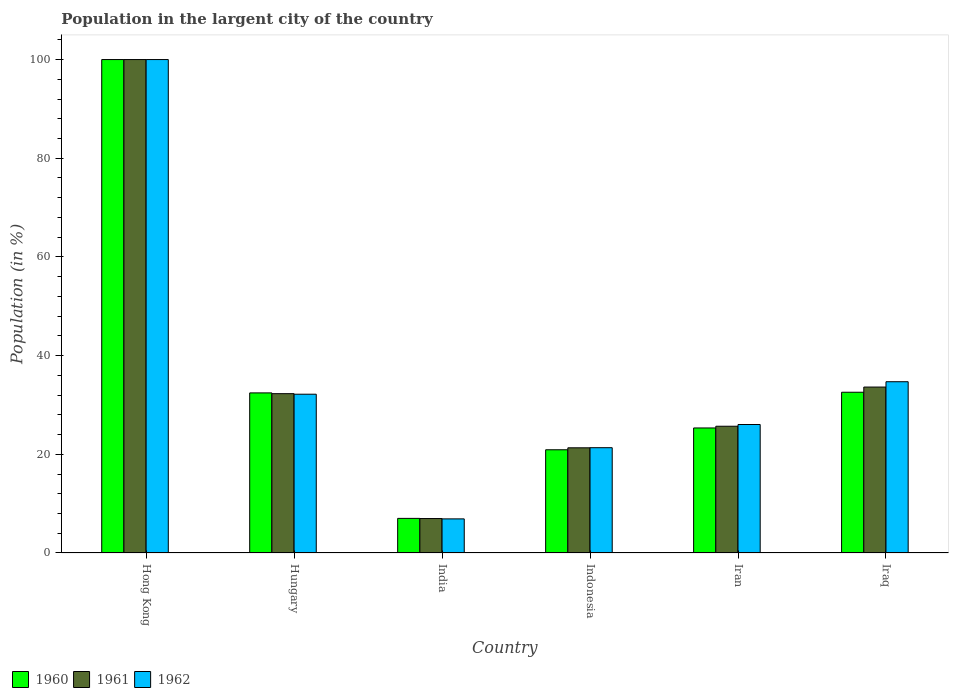How many different coloured bars are there?
Ensure brevity in your answer.  3. How many groups of bars are there?
Provide a short and direct response. 6. Are the number of bars per tick equal to the number of legend labels?
Your answer should be very brief. Yes. How many bars are there on the 1st tick from the left?
Give a very brief answer. 3. How many bars are there on the 3rd tick from the right?
Your response must be concise. 3. What is the label of the 1st group of bars from the left?
Offer a very short reply. Hong Kong. In how many cases, is the number of bars for a given country not equal to the number of legend labels?
Keep it short and to the point. 0. What is the percentage of population in the largent city in 1961 in India?
Make the answer very short. 6.98. Across all countries, what is the maximum percentage of population in the largent city in 1962?
Ensure brevity in your answer.  100. Across all countries, what is the minimum percentage of population in the largent city in 1961?
Make the answer very short. 6.98. In which country was the percentage of population in the largent city in 1961 maximum?
Your response must be concise. Hong Kong. What is the total percentage of population in the largent city in 1962 in the graph?
Your answer should be very brief. 221.17. What is the difference between the percentage of population in the largent city in 1962 in Hungary and that in Iran?
Provide a short and direct response. 6.14. What is the difference between the percentage of population in the largent city in 1961 in Iraq and the percentage of population in the largent city in 1960 in Indonesia?
Offer a very short reply. 12.71. What is the average percentage of population in the largent city in 1962 per country?
Make the answer very short. 36.86. What is the difference between the percentage of population in the largent city of/in 1960 and percentage of population in the largent city of/in 1961 in India?
Make the answer very short. 0.03. In how many countries, is the percentage of population in the largent city in 1962 greater than 96 %?
Offer a terse response. 1. What is the ratio of the percentage of population in the largent city in 1961 in Hong Kong to that in Iraq?
Your answer should be very brief. 2.97. What is the difference between the highest and the second highest percentage of population in the largent city in 1960?
Offer a terse response. 0.13. What is the difference between the highest and the lowest percentage of population in the largent city in 1961?
Keep it short and to the point. 93.02. In how many countries, is the percentage of population in the largent city in 1961 greater than the average percentage of population in the largent city in 1961 taken over all countries?
Ensure brevity in your answer.  1. What does the 2nd bar from the left in Iran represents?
Your response must be concise. 1961. What does the 1st bar from the right in Iran represents?
Make the answer very short. 1962. What is the difference between two consecutive major ticks on the Y-axis?
Your response must be concise. 20. Are the values on the major ticks of Y-axis written in scientific E-notation?
Your response must be concise. No. Does the graph contain any zero values?
Provide a short and direct response. No. Where does the legend appear in the graph?
Provide a succinct answer. Bottom left. How many legend labels are there?
Your answer should be compact. 3. What is the title of the graph?
Provide a succinct answer. Population in the largent city of the country. Does "1983" appear as one of the legend labels in the graph?
Give a very brief answer. No. What is the label or title of the X-axis?
Keep it short and to the point. Country. What is the label or title of the Y-axis?
Ensure brevity in your answer.  Population (in %). What is the Population (in %) of 1960 in Hong Kong?
Your answer should be compact. 100. What is the Population (in %) of 1960 in Hungary?
Keep it short and to the point. 32.44. What is the Population (in %) of 1961 in Hungary?
Make the answer very short. 32.29. What is the Population (in %) of 1962 in Hungary?
Provide a succinct answer. 32.18. What is the Population (in %) in 1960 in India?
Provide a short and direct response. 7.01. What is the Population (in %) of 1961 in India?
Your answer should be very brief. 6.98. What is the Population (in %) in 1962 in India?
Offer a terse response. 6.91. What is the Population (in %) of 1960 in Indonesia?
Your answer should be compact. 20.92. What is the Population (in %) in 1961 in Indonesia?
Provide a succinct answer. 21.32. What is the Population (in %) of 1962 in Indonesia?
Your answer should be very brief. 21.34. What is the Population (in %) of 1960 in Iran?
Make the answer very short. 25.34. What is the Population (in %) of 1961 in Iran?
Offer a terse response. 25.68. What is the Population (in %) in 1962 in Iran?
Your answer should be compact. 26.04. What is the Population (in %) of 1960 in Iraq?
Offer a very short reply. 32.58. What is the Population (in %) in 1961 in Iraq?
Keep it short and to the point. 33.63. What is the Population (in %) in 1962 in Iraq?
Make the answer very short. 34.71. Across all countries, what is the minimum Population (in %) of 1960?
Your response must be concise. 7.01. Across all countries, what is the minimum Population (in %) of 1961?
Provide a short and direct response. 6.98. Across all countries, what is the minimum Population (in %) of 1962?
Provide a short and direct response. 6.91. What is the total Population (in %) of 1960 in the graph?
Give a very brief answer. 218.29. What is the total Population (in %) of 1961 in the graph?
Give a very brief answer. 219.9. What is the total Population (in %) in 1962 in the graph?
Make the answer very short. 221.17. What is the difference between the Population (in %) in 1960 in Hong Kong and that in Hungary?
Provide a short and direct response. 67.56. What is the difference between the Population (in %) in 1961 in Hong Kong and that in Hungary?
Provide a short and direct response. 67.71. What is the difference between the Population (in %) of 1962 in Hong Kong and that in Hungary?
Your answer should be compact. 67.82. What is the difference between the Population (in %) of 1960 in Hong Kong and that in India?
Ensure brevity in your answer.  92.99. What is the difference between the Population (in %) in 1961 in Hong Kong and that in India?
Keep it short and to the point. 93.02. What is the difference between the Population (in %) in 1962 in Hong Kong and that in India?
Your response must be concise. 93.09. What is the difference between the Population (in %) of 1960 in Hong Kong and that in Indonesia?
Offer a very short reply. 79.08. What is the difference between the Population (in %) in 1961 in Hong Kong and that in Indonesia?
Keep it short and to the point. 78.68. What is the difference between the Population (in %) of 1962 in Hong Kong and that in Indonesia?
Give a very brief answer. 78.66. What is the difference between the Population (in %) of 1960 in Hong Kong and that in Iran?
Provide a succinct answer. 74.66. What is the difference between the Population (in %) in 1961 in Hong Kong and that in Iran?
Keep it short and to the point. 74.32. What is the difference between the Population (in %) of 1962 in Hong Kong and that in Iran?
Keep it short and to the point. 73.96. What is the difference between the Population (in %) in 1960 in Hong Kong and that in Iraq?
Ensure brevity in your answer.  67.42. What is the difference between the Population (in %) of 1961 in Hong Kong and that in Iraq?
Ensure brevity in your answer.  66.37. What is the difference between the Population (in %) in 1962 in Hong Kong and that in Iraq?
Make the answer very short. 65.29. What is the difference between the Population (in %) in 1960 in Hungary and that in India?
Give a very brief answer. 25.43. What is the difference between the Population (in %) in 1961 in Hungary and that in India?
Keep it short and to the point. 25.31. What is the difference between the Population (in %) of 1962 in Hungary and that in India?
Provide a succinct answer. 25.27. What is the difference between the Population (in %) of 1960 in Hungary and that in Indonesia?
Your answer should be compact. 11.53. What is the difference between the Population (in %) of 1961 in Hungary and that in Indonesia?
Your answer should be very brief. 10.97. What is the difference between the Population (in %) of 1962 in Hungary and that in Indonesia?
Provide a short and direct response. 10.84. What is the difference between the Population (in %) in 1960 in Hungary and that in Iran?
Make the answer very short. 7.11. What is the difference between the Population (in %) in 1961 in Hungary and that in Iran?
Your answer should be compact. 6.6. What is the difference between the Population (in %) in 1962 in Hungary and that in Iran?
Make the answer very short. 6.14. What is the difference between the Population (in %) of 1960 in Hungary and that in Iraq?
Give a very brief answer. -0.13. What is the difference between the Population (in %) in 1961 in Hungary and that in Iraq?
Keep it short and to the point. -1.34. What is the difference between the Population (in %) in 1962 in Hungary and that in Iraq?
Offer a terse response. -2.53. What is the difference between the Population (in %) in 1960 in India and that in Indonesia?
Give a very brief answer. -13.91. What is the difference between the Population (in %) of 1961 in India and that in Indonesia?
Keep it short and to the point. -14.33. What is the difference between the Population (in %) of 1962 in India and that in Indonesia?
Offer a terse response. -14.43. What is the difference between the Population (in %) in 1960 in India and that in Iran?
Provide a short and direct response. -18.33. What is the difference between the Population (in %) of 1961 in India and that in Iran?
Offer a very short reply. -18.7. What is the difference between the Population (in %) in 1962 in India and that in Iran?
Your answer should be very brief. -19.13. What is the difference between the Population (in %) in 1960 in India and that in Iraq?
Provide a succinct answer. -25.57. What is the difference between the Population (in %) in 1961 in India and that in Iraq?
Ensure brevity in your answer.  -26.64. What is the difference between the Population (in %) of 1962 in India and that in Iraq?
Your answer should be compact. -27.8. What is the difference between the Population (in %) in 1960 in Indonesia and that in Iran?
Provide a short and direct response. -4.42. What is the difference between the Population (in %) of 1961 in Indonesia and that in Iran?
Give a very brief answer. -4.37. What is the difference between the Population (in %) in 1962 in Indonesia and that in Iran?
Provide a short and direct response. -4.7. What is the difference between the Population (in %) of 1960 in Indonesia and that in Iraq?
Your answer should be very brief. -11.66. What is the difference between the Population (in %) in 1961 in Indonesia and that in Iraq?
Provide a succinct answer. -12.31. What is the difference between the Population (in %) in 1962 in Indonesia and that in Iraq?
Your answer should be compact. -13.37. What is the difference between the Population (in %) of 1960 in Iran and that in Iraq?
Ensure brevity in your answer.  -7.24. What is the difference between the Population (in %) in 1961 in Iran and that in Iraq?
Ensure brevity in your answer.  -7.94. What is the difference between the Population (in %) in 1962 in Iran and that in Iraq?
Keep it short and to the point. -8.67. What is the difference between the Population (in %) in 1960 in Hong Kong and the Population (in %) in 1961 in Hungary?
Make the answer very short. 67.71. What is the difference between the Population (in %) of 1960 in Hong Kong and the Population (in %) of 1962 in Hungary?
Give a very brief answer. 67.82. What is the difference between the Population (in %) in 1961 in Hong Kong and the Population (in %) in 1962 in Hungary?
Offer a terse response. 67.82. What is the difference between the Population (in %) of 1960 in Hong Kong and the Population (in %) of 1961 in India?
Your answer should be compact. 93.02. What is the difference between the Population (in %) of 1960 in Hong Kong and the Population (in %) of 1962 in India?
Your answer should be compact. 93.09. What is the difference between the Population (in %) of 1961 in Hong Kong and the Population (in %) of 1962 in India?
Ensure brevity in your answer.  93.09. What is the difference between the Population (in %) of 1960 in Hong Kong and the Population (in %) of 1961 in Indonesia?
Provide a succinct answer. 78.68. What is the difference between the Population (in %) of 1960 in Hong Kong and the Population (in %) of 1962 in Indonesia?
Offer a very short reply. 78.66. What is the difference between the Population (in %) in 1961 in Hong Kong and the Population (in %) in 1962 in Indonesia?
Give a very brief answer. 78.66. What is the difference between the Population (in %) of 1960 in Hong Kong and the Population (in %) of 1961 in Iran?
Give a very brief answer. 74.32. What is the difference between the Population (in %) of 1960 in Hong Kong and the Population (in %) of 1962 in Iran?
Provide a succinct answer. 73.96. What is the difference between the Population (in %) of 1961 in Hong Kong and the Population (in %) of 1962 in Iran?
Your answer should be compact. 73.96. What is the difference between the Population (in %) in 1960 in Hong Kong and the Population (in %) in 1961 in Iraq?
Your answer should be very brief. 66.37. What is the difference between the Population (in %) of 1960 in Hong Kong and the Population (in %) of 1962 in Iraq?
Keep it short and to the point. 65.29. What is the difference between the Population (in %) of 1961 in Hong Kong and the Population (in %) of 1962 in Iraq?
Your answer should be very brief. 65.29. What is the difference between the Population (in %) of 1960 in Hungary and the Population (in %) of 1961 in India?
Provide a succinct answer. 25.46. What is the difference between the Population (in %) in 1960 in Hungary and the Population (in %) in 1962 in India?
Provide a succinct answer. 25.53. What is the difference between the Population (in %) of 1961 in Hungary and the Population (in %) of 1962 in India?
Keep it short and to the point. 25.38. What is the difference between the Population (in %) in 1960 in Hungary and the Population (in %) in 1961 in Indonesia?
Give a very brief answer. 11.13. What is the difference between the Population (in %) of 1960 in Hungary and the Population (in %) of 1962 in Indonesia?
Your answer should be compact. 11.11. What is the difference between the Population (in %) in 1961 in Hungary and the Population (in %) in 1962 in Indonesia?
Offer a very short reply. 10.95. What is the difference between the Population (in %) of 1960 in Hungary and the Population (in %) of 1961 in Iran?
Give a very brief answer. 6.76. What is the difference between the Population (in %) of 1960 in Hungary and the Population (in %) of 1962 in Iran?
Ensure brevity in your answer.  6.41. What is the difference between the Population (in %) of 1961 in Hungary and the Population (in %) of 1962 in Iran?
Keep it short and to the point. 6.25. What is the difference between the Population (in %) in 1960 in Hungary and the Population (in %) in 1961 in Iraq?
Your answer should be very brief. -1.18. What is the difference between the Population (in %) of 1960 in Hungary and the Population (in %) of 1962 in Iraq?
Your answer should be very brief. -2.26. What is the difference between the Population (in %) in 1961 in Hungary and the Population (in %) in 1962 in Iraq?
Your answer should be compact. -2.42. What is the difference between the Population (in %) in 1960 in India and the Population (in %) in 1961 in Indonesia?
Provide a succinct answer. -14.3. What is the difference between the Population (in %) of 1960 in India and the Population (in %) of 1962 in Indonesia?
Your response must be concise. -14.32. What is the difference between the Population (in %) in 1961 in India and the Population (in %) in 1962 in Indonesia?
Make the answer very short. -14.35. What is the difference between the Population (in %) in 1960 in India and the Population (in %) in 1961 in Iran?
Offer a terse response. -18.67. What is the difference between the Population (in %) in 1960 in India and the Population (in %) in 1962 in Iran?
Your answer should be compact. -19.02. What is the difference between the Population (in %) of 1961 in India and the Population (in %) of 1962 in Iran?
Ensure brevity in your answer.  -19.06. What is the difference between the Population (in %) of 1960 in India and the Population (in %) of 1961 in Iraq?
Your answer should be compact. -26.61. What is the difference between the Population (in %) of 1960 in India and the Population (in %) of 1962 in Iraq?
Offer a terse response. -27.69. What is the difference between the Population (in %) in 1961 in India and the Population (in %) in 1962 in Iraq?
Give a very brief answer. -27.72. What is the difference between the Population (in %) of 1960 in Indonesia and the Population (in %) of 1961 in Iran?
Provide a succinct answer. -4.77. What is the difference between the Population (in %) in 1960 in Indonesia and the Population (in %) in 1962 in Iran?
Your answer should be very brief. -5.12. What is the difference between the Population (in %) in 1961 in Indonesia and the Population (in %) in 1962 in Iran?
Provide a succinct answer. -4.72. What is the difference between the Population (in %) in 1960 in Indonesia and the Population (in %) in 1961 in Iraq?
Keep it short and to the point. -12.71. What is the difference between the Population (in %) of 1960 in Indonesia and the Population (in %) of 1962 in Iraq?
Your answer should be very brief. -13.79. What is the difference between the Population (in %) of 1961 in Indonesia and the Population (in %) of 1962 in Iraq?
Offer a terse response. -13.39. What is the difference between the Population (in %) of 1960 in Iran and the Population (in %) of 1961 in Iraq?
Provide a succinct answer. -8.29. What is the difference between the Population (in %) in 1960 in Iran and the Population (in %) in 1962 in Iraq?
Your response must be concise. -9.37. What is the difference between the Population (in %) in 1961 in Iran and the Population (in %) in 1962 in Iraq?
Your response must be concise. -9.02. What is the average Population (in %) of 1960 per country?
Your answer should be very brief. 36.38. What is the average Population (in %) in 1961 per country?
Give a very brief answer. 36.65. What is the average Population (in %) of 1962 per country?
Provide a succinct answer. 36.86. What is the difference between the Population (in %) in 1960 and Population (in %) in 1962 in Hong Kong?
Ensure brevity in your answer.  0. What is the difference between the Population (in %) in 1960 and Population (in %) in 1961 in Hungary?
Ensure brevity in your answer.  0.16. What is the difference between the Population (in %) of 1960 and Population (in %) of 1962 in Hungary?
Ensure brevity in your answer.  0.27. What is the difference between the Population (in %) of 1961 and Population (in %) of 1962 in Hungary?
Offer a terse response. 0.11. What is the difference between the Population (in %) in 1960 and Population (in %) in 1961 in India?
Provide a short and direct response. 0.03. What is the difference between the Population (in %) in 1960 and Population (in %) in 1962 in India?
Offer a terse response. 0.1. What is the difference between the Population (in %) of 1961 and Population (in %) of 1962 in India?
Offer a terse response. 0.07. What is the difference between the Population (in %) of 1960 and Population (in %) of 1961 in Indonesia?
Ensure brevity in your answer.  -0.4. What is the difference between the Population (in %) in 1960 and Population (in %) in 1962 in Indonesia?
Make the answer very short. -0.42. What is the difference between the Population (in %) of 1961 and Population (in %) of 1962 in Indonesia?
Your response must be concise. -0.02. What is the difference between the Population (in %) in 1960 and Population (in %) in 1961 in Iran?
Provide a succinct answer. -0.35. What is the difference between the Population (in %) in 1960 and Population (in %) in 1962 in Iran?
Provide a short and direct response. -0.7. What is the difference between the Population (in %) of 1961 and Population (in %) of 1962 in Iran?
Offer a very short reply. -0.35. What is the difference between the Population (in %) in 1960 and Population (in %) in 1961 in Iraq?
Your response must be concise. -1.05. What is the difference between the Population (in %) in 1960 and Population (in %) in 1962 in Iraq?
Offer a very short reply. -2.13. What is the difference between the Population (in %) in 1961 and Population (in %) in 1962 in Iraq?
Make the answer very short. -1.08. What is the ratio of the Population (in %) of 1960 in Hong Kong to that in Hungary?
Keep it short and to the point. 3.08. What is the ratio of the Population (in %) in 1961 in Hong Kong to that in Hungary?
Your answer should be very brief. 3.1. What is the ratio of the Population (in %) of 1962 in Hong Kong to that in Hungary?
Ensure brevity in your answer.  3.11. What is the ratio of the Population (in %) of 1960 in Hong Kong to that in India?
Your answer should be very brief. 14.26. What is the ratio of the Population (in %) in 1961 in Hong Kong to that in India?
Provide a succinct answer. 14.32. What is the ratio of the Population (in %) in 1962 in Hong Kong to that in India?
Ensure brevity in your answer.  14.47. What is the ratio of the Population (in %) of 1960 in Hong Kong to that in Indonesia?
Your response must be concise. 4.78. What is the ratio of the Population (in %) in 1961 in Hong Kong to that in Indonesia?
Provide a short and direct response. 4.69. What is the ratio of the Population (in %) of 1962 in Hong Kong to that in Indonesia?
Your response must be concise. 4.69. What is the ratio of the Population (in %) of 1960 in Hong Kong to that in Iran?
Ensure brevity in your answer.  3.95. What is the ratio of the Population (in %) of 1961 in Hong Kong to that in Iran?
Give a very brief answer. 3.89. What is the ratio of the Population (in %) in 1962 in Hong Kong to that in Iran?
Your answer should be compact. 3.84. What is the ratio of the Population (in %) in 1960 in Hong Kong to that in Iraq?
Offer a terse response. 3.07. What is the ratio of the Population (in %) of 1961 in Hong Kong to that in Iraq?
Your response must be concise. 2.97. What is the ratio of the Population (in %) of 1962 in Hong Kong to that in Iraq?
Provide a succinct answer. 2.88. What is the ratio of the Population (in %) in 1960 in Hungary to that in India?
Give a very brief answer. 4.63. What is the ratio of the Population (in %) in 1961 in Hungary to that in India?
Ensure brevity in your answer.  4.62. What is the ratio of the Population (in %) in 1962 in Hungary to that in India?
Offer a very short reply. 4.66. What is the ratio of the Population (in %) of 1960 in Hungary to that in Indonesia?
Your answer should be compact. 1.55. What is the ratio of the Population (in %) in 1961 in Hungary to that in Indonesia?
Your response must be concise. 1.51. What is the ratio of the Population (in %) in 1962 in Hungary to that in Indonesia?
Offer a terse response. 1.51. What is the ratio of the Population (in %) of 1960 in Hungary to that in Iran?
Provide a succinct answer. 1.28. What is the ratio of the Population (in %) in 1961 in Hungary to that in Iran?
Keep it short and to the point. 1.26. What is the ratio of the Population (in %) in 1962 in Hungary to that in Iran?
Provide a succinct answer. 1.24. What is the ratio of the Population (in %) of 1960 in Hungary to that in Iraq?
Your answer should be very brief. 1. What is the ratio of the Population (in %) of 1961 in Hungary to that in Iraq?
Your answer should be very brief. 0.96. What is the ratio of the Population (in %) in 1962 in Hungary to that in Iraq?
Your response must be concise. 0.93. What is the ratio of the Population (in %) of 1960 in India to that in Indonesia?
Provide a short and direct response. 0.34. What is the ratio of the Population (in %) in 1961 in India to that in Indonesia?
Offer a very short reply. 0.33. What is the ratio of the Population (in %) of 1962 in India to that in Indonesia?
Your response must be concise. 0.32. What is the ratio of the Population (in %) of 1960 in India to that in Iran?
Keep it short and to the point. 0.28. What is the ratio of the Population (in %) of 1961 in India to that in Iran?
Offer a terse response. 0.27. What is the ratio of the Population (in %) in 1962 in India to that in Iran?
Keep it short and to the point. 0.27. What is the ratio of the Population (in %) in 1960 in India to that in Iraq?
Provide a succinct answer. 0.22. What is the ratio of the Population (in %) of 1961 in India to that in Iraq?
Your answer should be very brief. 0.21. What is the ratio of the Population (in %) in 1962 in India to that in Iraq?
Keep it short and to the point. 0.2. What is the ratio of the Population (in %) in 1960 in Indonesia to that in Iran?
Offer a terse response. 0.83. What is the ratio of the Population (in %) in 1961 in Indonesia to that in Iran?
Offer a very short reply. 0.83. What is the ratio of the Population (in %) of 1962 in Indonesia to that in Iran?
Make the answer very short. 0.82. What is the ratio of the Population (in %) in 1960 in Indonesia to that in Iraq?
Offer a very short reply. 0.64. What is the ratio of the Population (in %) of 1961 in Indonesia to that in Iraq?
Give a very brief answer. 0.63. What is the ratio of the Population (in %) of 1962 in Indonesia to that in Iraq?
Your answer should be compact. 0.61. What is the ratio of the Population (in %) of 1961 in Iran to that in Iraq?
Make the answer very short. 0.76. What is the ratio of the Population (in %) of 1962 in Iran to that in Iraq?
Keep it short and to the point. 0.75. What is the difference between the highest and the second highest Population (in %) in 1960?
Keep it short and to the point. 67.42. What is the difference between the highest and the second highest Population (in %) of 1961?
Offer a very short reply. 66.37. What is the difference between the highest and the second highest Population (in %) in 1962?
Provide a short and direct response. 65.29. What is the difference between the highest and the lowest Population (in %) in 1960?
Make the answer very short. 92.99. What is the difference between the highest and the lowest Population (in %) of 1961?
Offer a terse response. 93.02. What is the difference between the highest and the lowest Population (in %) in 1962?
Make the answer very short. 93.09. 